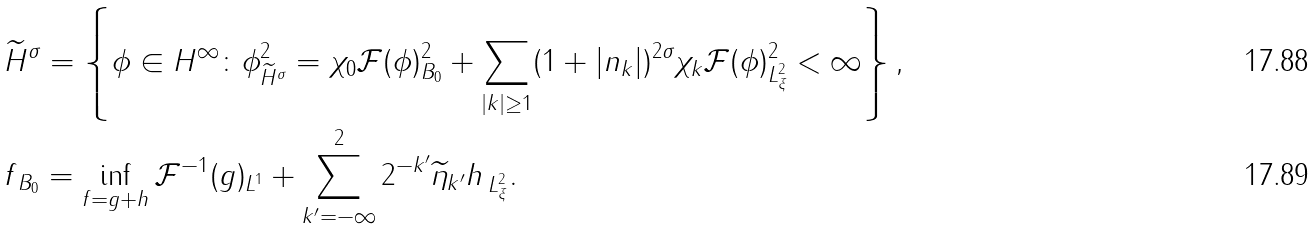Convert formula to latex. <formula><loc_0><loc_0><loc_500><loc_500>& \widetilde { H } ^ { \sigma } = \left \{ \phi \in H ^ { \infty } \colon \| \phi \| _ { \widetilde { H } ^ { \sigma } } ^ { 2 } = \| \chi _ { 0 } \mathcal { F } ( \phi ) \| ^ { 2 } _ { B _ { 0 } } + \sum _ { | k | \geq 1 } ( 1 + | n _ { k } | ) ^ { 2 \sigma } \| \chi _ { k } \mathcal { F } ( \phi ) \| _ { L ^ { 2 } _ { \xi } } ^ { 2 } < \infty \right \} , \\ & \| f \| _ { B _ { 0 } } = \inf _ { f = g + h } \| \mathcal { F } ^ { - 1 } ( g ) \| _ { L ^ { 1 } } + \sum _ { k ^ { \prime } = - \infty } ^ { 2 } 2 ^ { - k ^ { \prime } } \| \widetilde { \eta } _ { k ^ { \prime } } h \, \| _ { L ^ { 2 } _ { \xi } } .</formula> 